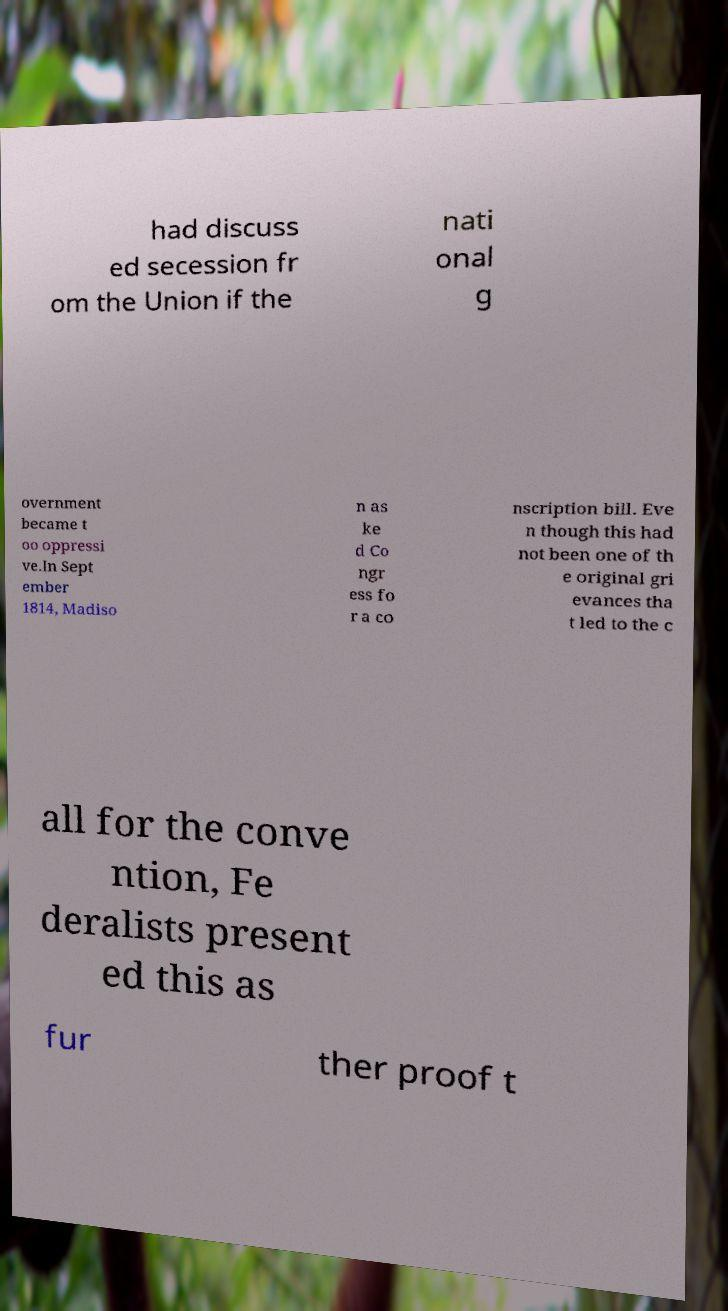What messages or text are displayed in this image? I need them in a readable, typed format. had discuss ed secession fr om the Union if the nati onal g overnment became t oo oppressi ve.In Sept ember 1814, Madiso n as ke d Co ngr ess fo r a co nscription bill. Eve n though this had not been one of th e original gri evances tha t led to the c all for the conve ntion, Fe deralists present ed this as fur ther proof t 